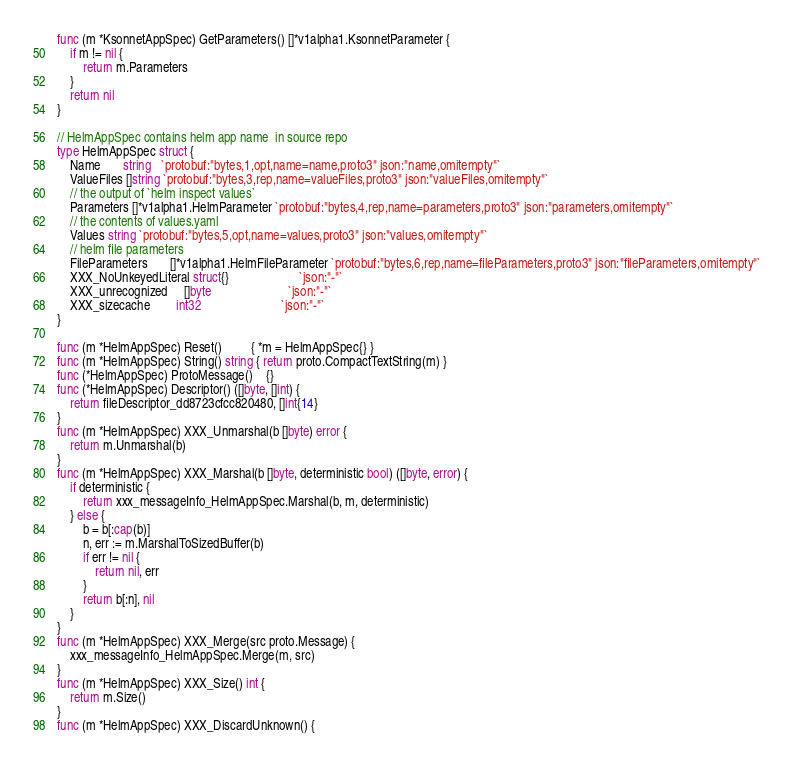Convert code to text. <code><loc_0><loc_0><loc_500><loc_500><_Go_>func (m *KsonnetAppSpec) GetParameters() []*v1alpha1.KsonnetParameter {
	if m != nil {
		return m.Parameters
	}
	return nil
}

// HelmAppSpec contains helm app name  in source repo
type HelmAppSpec struct {
	Name       string   `protobuf:"bytes,1,opt,name=name,proto3" json:"name,omitempty"`
	ValueFiles []string `protobuf:"bytes,3,rep,name=valueFiles,proto3" json:"valueFiles,omitempty"`
	// the output of `helm inspect values`
	Parameters []*v1alpha1.HelmParameter `protobuf:"bytes,4,rep,name=parameters,proto3" json:"parameters,omitempty"`
	// the contents of values.yaml
	Values string `protobuf:"bytes,5,opt,name=values,proto3" json:"values,omitempty"`
	// helm file parameters
	FileParameters       []*v1alpha1.HelmFileParameter `protobuf:"bytes,6,rep,name=fileParameters,proto3" json:"fileParameters,omitempty"`
	XXX_NoUnkeyedLiteral struct{}                      `json:"-"`
	XXX_unrecognized     []byte                        `json:"-"`
	XXX_sizecache        int32                         `json:"-"`
}

func (m *HelmAppSpec) Reset()         { *m = HelmAppSpec{} }
func (m *HelmAppSpec) String() string { return proto.CompactTextString(m) }
func (*HelmAppSpec) ProtoMessage()    {}
func (*HelmAppSpec) Descriptor() ([]byte, []int) {
	return fileDescriptor_dd8723cfcc820480, []int{14}
}
func (m *HelmAppSpec) XXX_Unmarshal(b []byte) error {
	return m.Unmarshal(b)
}
func (m *HelmAppSpec) XXX_Marshal(b []byte, deterministic bool) ([]byte, error) {
	if deterministic {
		return xxx_messageInfo_HelmAppSpec.Marshal(b, m, deterministic)
	} else {
		b = b[:cap(b)]
		n, err := m.MarshalToSizedBuffer(b)
		if err != nil {
			return nil, err
		}
		return b[:n], nil
	}
}
func (m *HelmAppSpec) XXX_Merge(src proto.Message) {
	xxx_messageInfo_HelmAppSpec.Merge(m, src)
}
func (m *HelmAppSpec) XXX_Size() int {
	return m.Size()
}
func (m *HelmAppSpec) XXX_DiscardUnknown() {</code> 